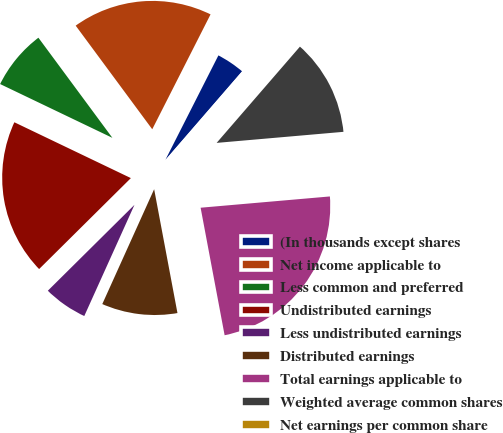<chart> <loc_0><loc_0><loc_500><loc_500><pie_chart><fcel>(In thousands except shares<fcel>Net income applicable to<fcel>Less common and preferred<fcel>Undistributed earnings<fcel>Less undistributed earnings<fcel>Distributed earnings<fcel>Total earnings applicable to<fcel>Weighted average common shares<fcel>Net earnings per common share<nl><fcel>3.88%<fcel>17.6%<fcel>7.76%<fcel>19.54%<fcel>5.82%<fcel>9.71%<fcel>23.42%<fcel>12.26%<fcel>0.0%<nl></chart> 